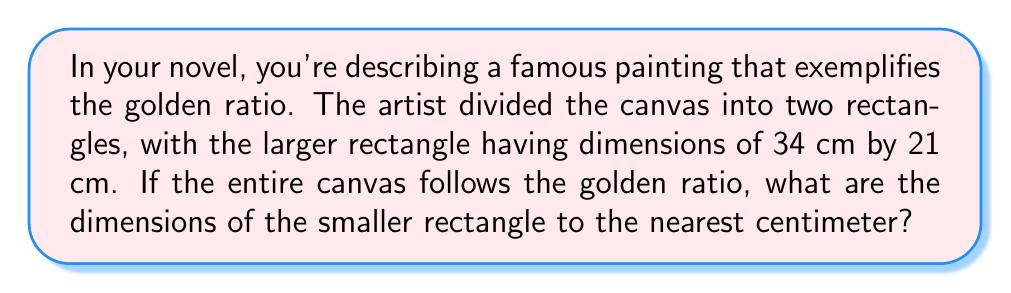Show me your answer to this math problem. To solve this problem, we'll use the properties of the golden ratio and the given information:

1) The golden ratio, denoted by $\phi$, is approximately 1.618034...

2) In a golden rectangle, the ratio of the longer side to the shorter side is $\phi$.

3) We're given that the larger rectangle is 34 cm by 21 cm.

4) Let's denote the width of the smaller rectangle as $x$ cm.

5) The golden ratio property implies:
   $$\frac{34}{21} = \frac{21}{x}$$

6) Cross multiply:
   $$34x = 21 \cdot 21 = 441$$

7) Solve for $x$:
   $$x = \frac{441}{34} \approx 12.97 \text{ cm}$$

8) Rounding to the nearest centimeter:
   $x \approx 13 \text{ cm}$

9) The height of the smaller rectangle is the same as the larger one: 21 cm.

Therefore, the dimensions of the smaller rectangle are approximately 13 cm by 21 cm.
Answer: 13 cm × 21 cm 